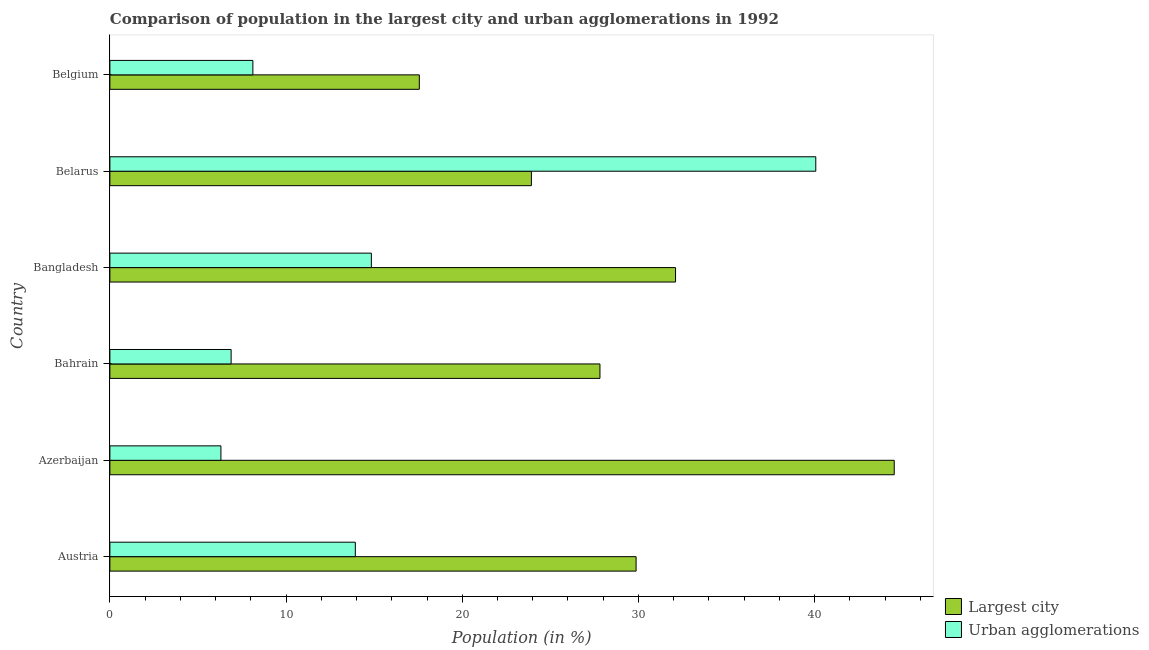How many different coloured bars are there?
Your answer should be compact. 2. How many groups of bars are there?
Offer a very short reply. 6. Are the number of bars per tick equal to the number of legend labels?
Offer a terse response. Yes. Are the number of bars on each tick of the Y-axis equal?
Your response must be concise. Yes. What is the label of the 3rd group of bars from the top?
Provide a short and direct response. Bangladesh. In how many cases, is the number of bars for a given country not equal to the number of legend labels?
Ensure brevity in your answer.  0. What is the population in urban agglomerations in Austria?
Your answer should be very brief. 13.93. Across all countries, what is the maximum population in urban agglomerations?
Offer a very short reply. 40.07. Across all countries, what is the minimum population in urban agglomerations?
Give a very brief answer. 6.3. In which country was the population in the largest city maximum?
Your answer should be very brief. Azerbaijan. In which country was the population in urban agglomerations minimum?
Give a very brief answer. Azerbaijan. What is the total population in urban agglomerations in the graph?
Provide a short and direct response. 90.14. What is the difference between the population in the largest city in Bahrain and that in Bangladesh?
Provide a succinct answer. -4.29. What is the difference between the population in urban agglomerations in Bangladesh and the population in the largest city in Belgium?
Make the answer very short. -2.72. What is the average population in the largest city per country?
Keep it short and to the point. 29.3. What is the difference between the population in the largest city and population in urban agglomerations in Bahrain?
Provide a short and direct response. 20.94. In how many countries, is the population in the largest city greater than 22 %?
Provide a short and direct response. 5. What is the ratio of the population in the largest city in Austria to that in Azerbaijan?
Your answer should be very brief. 0.67. What is the difference between the highest and the second highest population in urban agglomerations?
Provide a short and direct response. 25.23. What is the difference between the highest and the lowest population in urban agglomerations?
Your response must be concise. 33.77. What does the 2nd bar from the top in Austria represents?
Make the answer very short. Largest city. What does the 2nd bar from the bottom in Bahrain represents?
Keep it short and to the point. Urban agglomerations. Are all the bars in the graph horizontal?
Offer a very short reply. Yes. How many countries are there in the graph?
Your answer should be very brief. 6. Does the graph contain grids?
Your answer should be very brief. No. How many legend labels are there?
Your response must be concise. 2. How are the legend labels stacked?
Make the answer very short. Vertical. What is the title of the graph?
Your answer should be very brief. Comparison of population in the largest city and urban agglomerations in 1992. Does "Fixed telephone" appear as one of the legend labels in the graph?
Keep it short and to the point. No. What is the Population (in %) in Largest city in Austria?
Keep it short and to the point. 29.87. What is the Population (in %) in Urban agglomerations in Austria?
Provide a short and direct response. 13.93. What is the Population (in %) of Largest city in Azerbaijan?
Your response must be concise. 44.52. What is the Population (in %) of Urban agglomerations in Azerbaijan?
Give a very brief answer. 6.3. What is the Population (in %) in Largest city in Bahrain?
Give a very brief answer. 27.82. What is the Population (in %) in Urban agglomerations in Bahrain?
Ensure brevity in your answer.  6.88. What is the Population (in %) of Largest city in Bangladesh?
Offer a very short reply. 32.11. What is the Population (in %) of Urban agglomerations in Bangladesh?
Offer a very short reply. 14.84. What is the Population (in %) of Largest city in Belarus?
Keep it short and to the point. 23.93. What is the Population (in %) in Urban agglomerations in Belarus?
Your response must be concise. 40.07. What is the Population (in %) in Largest city in Belgium?
Your answer should be very brief. 17.56. What is the Population (in %) of Urban agglomerations in Belgium?
Give a very brief answer. 8.12. Across all countries, what is the maximum Population (in %) in Largest city?
Ensure brevity in your answer.  44.52. Across all countries, what is the maximum Population (in %) of Urban agglomerations?
Ensure brevity in your answer.  40.07. Across all countries, what is the minimum Population (in %) of Largest city?
Your answer should be very brief. 17.56. Across all countries, what is the minimum Population (in %) in Urban agglomerations?
Offer a terse response. 6.3. What is the total Population (in %) in Largest city in the graph?
Provide a succinct answer. 175.81. What is the total Population (in %) of Urban agglomerations in the graph?
Offer a terse response. 90.14. What is the difference between the Population (in %) of Largest city in Austria and that in Azerbaijan?
Keep it short and to the point. -14.65. What is the difference between the Population (in %) of Urban agglomerations in Austria and that in Azerbaijan?
Your response must be concise. 7.63. What is the difference between the Population (in %) of Largest city in Austria and that in Bahrain?
Make the answer very short. 2.05. What is the difference between the Population (in %) of Urban agglomerations in Austria and that in Bahrain?
Offer a very short reply. 7.05. What is the difference between the Population (in %) in Largest city in Austria and that in Bangladesh?
Provide a short and direct response. -2.24. What is the difference between the Population (in %) in Urban agglomerations in Austria and that in Bangladesh?
Your answer should be very brief. -0.91. What is the difference between the Population (in %) in Largest city in Austria and that in Belarus?
Offer a terse response. 5.94. What is the difference between the Population (in %) of Urban agglomerations in Austria and that in Belarus?
Give a very brief answer. -26.14. What is the difference between the Population (in %) in Largest city in Austria and that in Belgium?
Provide a succinct answer. 12.31. What is the difference between the Population (in %) in Urban agglomerations in Austria and that in Belgium?
Give a very brief answer. 5.82. What is the difference between the Population (in %) of Largest city in Azerbaijan and that in Bahrain?
Keep it short and to the point. 16.7. What is the difference between the Population (in %) of Urban agglomerations in Azerbaijan and that in Bahrain?
Make the answer very short. -0.58. What is the difference between the Population (in %) of Largest city in Azerbaijan and that in Bangladesh?
Give a very brief answer. 12.41. What is the difference between the Population (in %) in Urban agglomerations in Azerbaijan and that in Bangladesh?
Your answer should be very brief. -8.54. What is the difference between the Population (in %) in Largest city in Azerbaijan and that in Belarus?
Keep it short and to the point. 20.6. What is the difference between the Population (in %) of Urban agglomerations in Azerbaijan and that in Belarus?
Offer a very short reply. -33.77. What is the difference between the Population (in %) of Largest city in Azerbaijan and that in Belgium?
Provide a succinct answer. 26.96. What is the difference between the Population (in %) of Urban agglomerations in Azerbaijan and that in Belgium?
Provide a short and direct response. -1.81. What is the difference between the Population (in %) of Largest city in Bahrain and that in Bangladesh?
Your response must be concise. -4.29. What is the difference between the Population (in %) of Urban agglomerations in Bahrain and that in Bangladesh?
Provide a succinct answer. -7.96. What is the difference between the Population (in %) in Largest city in Bahrain and that in Belarus?
Offer a terse response. 3.89. What is the difference between the Population (in %) in Urban agglomerations in Bahrain and that in Belarus?
Provide a succinct answer. -33.19. What is the difference between the Population (in %) in Largest city in Bahrain and that in Belgium?
Provide a succinct answer. 10.25. What is the difference between the Population (in %) in Urban agglomerations in Bahrain and that in Belgium?
Provide a succinct answer. -1.23. What is the difference between the Population (in %) of Largest city in Bangladesh and that in Belarus?
Provide a short and direct response. 8.18. What is the difference between the Population (in %) in Urban agglomerations in Bangladesh and that in Belarus?
Keep it short and to the point. -25.23. What is the difference between the Population (in %) in Largest city in Bangladesh and that in Belgium?
Your answer should be compact. 14.54. What is the difference between the Population (in %) of Urban agglomerations in Bangladesh and that in Belgium?
Your response must be concise. 6.73. What is the difference between the Population (in %) in Largest city in Belarus and that in Belgium?
Keep it short and to the point. 6.36. What is the difference between the Population (in %) of Urban agglomerations in Belarus and that in Belgium?
Provide a short and direct response. 31.95. What is the difference between the Population (in %) in Largest city in Austria and the Population (in %) in Urban agglomerations in Azerbaijan?
Give a very brief answer. 23.57. What is the difference between the Population (in %) in Largest city in Austria and the Population (in %) in Urban agglomerations in Bahrain?
Provide a succinct answer. 22.99. What is the difference between the Population (in %) in Largest city in Austria and the Population (in %) in Urban agglomerations in Bangladesh?
Give a very brief answer. 15.03. What is the difference between the Population (in %) of Largest city in Austria and the Population (in %) of Urban agglomerations in Belarus?
Make the answer very short. -10.2. What is the difference between the Population (in %) in Largest city in Austria and the Population (in %) in Urban agglomerations in Belgium?
Provide a short and direct response. 21.75. What is the difference between the Population (in %) in Largest city in Azerbaijan and the Population (in %) in Urban agglomerations in Bahrain?
Give a very brief answer. 37.64. What is the difference between the Population (in %) in Largest city in Azerbaijan and the Population (in %) in Urban agglomerations in Bangladesh?
Offer a terse response. 29.68. What is the difference between the Population (in %) in Largest city in Azerbaijan and the Population (in %) in Urban agglomerations in Belarus?
Ensure brevity in your answer.  4.45. What is the difference between the Population (in %) of Largest city in Azerbaijan and the Population (in %) of Urban agglomerations in Belgium?
Give a very brief answer. 36.41. What is the difference between the Population (in %) in Largest city in Bahrain and the Population (in %) in Urban agglomerations in Bangladesh?
Provide a succinct answer. 12.98. What is the difference between the Population (in %) in Largest city in Bahrain and the Population (in %) in Urban agglomerations in Belarus?
Make the answer very short. -12.25. What is the difference between the Population (in %) of Largest city in Bahrain and the Population (in %) of Urban agglomerations in Belgium?
Provide a succinct answer. 19.7. What is the difference between the Population (in %) in Largest city in Bangladesh and the Population (in %) in Urban agglomerations in Belarus?
Provide a short and direct response. -7.96. What is the difference between the Population (in %) in Largest city in Bangladesh and the Population (in %) in Urban agglomerations in Belgium?
Ensure brevity in your answer.  23.99. What is the difference between the Population (in %) of Largest city in Belarus and the Population (in %) of Urban agglomerations in Belgium?
Keep it short and to the point. 15.81. What is the average Population (in %) of Largest city per country?
Provide a succinct answer. 29.3. What is the average Population (in %) of Urban agglomerations per country?
Provide a succinct answer. 15.02. What is the difference between the Population (in %) in Largest city and Population (in %) in Urban agglomerations in Austria?
Your answer should be compact. 15.94. What is the difference between the Population (in %) in Largest city and Population (in %) in Urban agglomerations in Azerbaijan?
Provide a short and direct response. 38.22. What is the difference between the Population (in %) of Largest city and Population (in %) of Urban agglomerations in Bahrain?
Offer a terse response. 20.94. What is the difference between the Population (in %) of Largest city and Population (in %) of Urban agglomerations in Bangladesh?
Keep it short and to the point. 17.27. What is the difference between the Population (in %) of Largest city and Population (in %) of Urban agglomerations in Belarus?
Your answer should be very brief. -16.14. What is the difference between the Population (in %) of Largest city and Population (in %) of Urban agglomerations in Belgium?
Provide a succinct answer. 9.45. What is the ratio of the Population (in %) in Largest city in Austria to that in Azerbaijan?
Offer a terse response. 0.67. What is the ratio of the Population (in %) in Urban agglomerations in Austria to that in Azerbaijan?
Ensure brevity in your answer.  2.21. What is the ratio of the Population (in %) of Largest city in Austria to that in Bahrain?
Your response must be concise. 1.07. What is the ratio of the Population (in %) of Urban agglomerations in Austria to that in Bahrain?
Your response must be concise. 2.02. What is the ratio of the Population (in %) in Largest city in Austria to that in Bangladesh?
Keep it short and to the point. 0.93. What is the ratio of the Population (in %) in Urban agglomerations in Austria to that in Bangladesh?
Your response must be concise. 0.94. What is the ratio of the Population (in %) in Largest city in Austria to that in Belarus?
Offer a terse response. 1.25. What is the ratio of the Population (in %) of Urban agglomerations in Austria to that in Belarus?
Provide a succinct answer. 0.35. What is the ratio of the Population (in %) of Largest city in Austria to that in Belgium?
Your answer should be compact. 1.7. What is the ratio of the Population (in %) of Urban agglomerations in Austria to that in Belgium?
Offer a very short reply. 1.72. What is the ratio of the Population (in %) of Largest city in Azerbaijan to that in Bahrain?
Give a very brief answer. 1.6. What is the ratio of the Population (in %) in Urban agglomerations in Azerbaijan to that in Bahrain?
Make the answer very short. 0.92. What is the ratio of the Population (in %) of Largest city in Azerbaijan to that in Bangladesh?
Give a very brief answer. 1.39. What is the ratio of the Population (in %) in Urban agglomerations in Azerbaijan to that in Bangladesh?
Your response must be concise. 0.42. What is the ratio of the Population (in %) of Largest city in Azerbaijan to that in Belarus?
Provide a succinct answer. 1.86. What is the ratio of the Population (in %) of Urban agglomerations in Azerbaijan to that in Belarus?
Ensure brevity in your answer.  0.16. What is the ratio of the Population (in %) of Largest city in Azerbaijan to that in Belgium?
Make the answer very short. 2.53. What is the ratio of the Population (in %) in Urban agglomerations in Azerbaijan to that in Belgium?
Keep it short and to the point. 0.78. What is the ratio of the Population (in %) of Largest city in Bahrain to that in Bangladesh?
Your response must be concise. 0.87. What is the ratio of the Population (in %) in Urban agglomerations in Bahrain to that in Bangladesh?
Offer a terse response. 0.46. What is the ratio of the Population (in %) of Largest city in Bahrain to that in Belarus?
Offer a terse response. 1.16. What is the ratio of the Population (in %) in Urban agglomerations in Bahrain to that in Belarus?
Your answer should be compact. 0.17. What is the ratio of the Population (in %) in Largest city in Bahrain to that in Belgium?
Offer a very short reply. 1.58. What is the ratio of the Population (in %) of Urban agglomerations in Bahrain to that in Belgium?
Ensure brevity in your answer.  0.85. What is the ratio of the Population (in %) of Largest city in Bangladesh to that in Belarus?
Keep it short and to the point. 1.34. What is the ratio of the Population (in %) in Urban agglomerations in Bangladesh to that in Belarus?
Give a very brief answer. 0.37. What is the ratio of the Population (in %) of Largest city in Bangladesh to that in Belgium?
Keep it short and to the point. 1.83. What is the ratio of the Population (in %) in Urban agglomerations in Bangladesh to that in Belgium?
Provide a succinct answer. 1.83. What is the ratio of the Population (in %) in Largest city in Belarus to that in Belgium?
Your answer should be compact. 1.36. What is the ratio of the Population (in %) of Urban agglomerations in Belarus to that in Belgium?
Your answer should be very brief. 4.94. What is the difference between the highest and the second highest Population (in %) in Largest city?
Keep it short and to the point. 12.41. What is the difference between the highest and the second highest Population (in %) of Urban agglomerations?
Your answer should be compact. 25.23. What is the difference between the highest and the lowest Population (in %) in Largest city?
Provide a short and direct response. 26.96. What is the difference between the highest and the lowest Population (in %) of Urban agglomerations?
Make the answer very short. 33.77. 